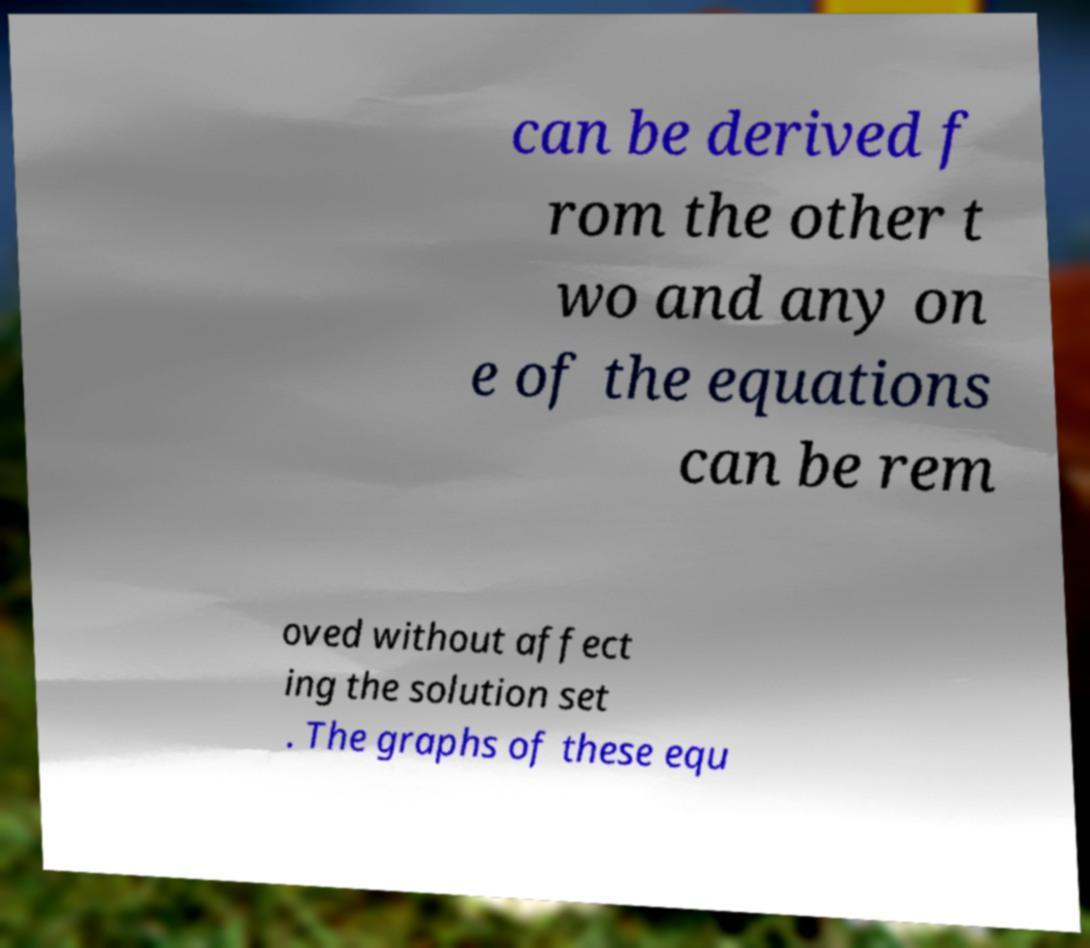Could you extract and type out the text from this image? can be derived f rom the other t wo and any on e of the equations can be rem oved without affect ing the solution set . The graphs of these equ 